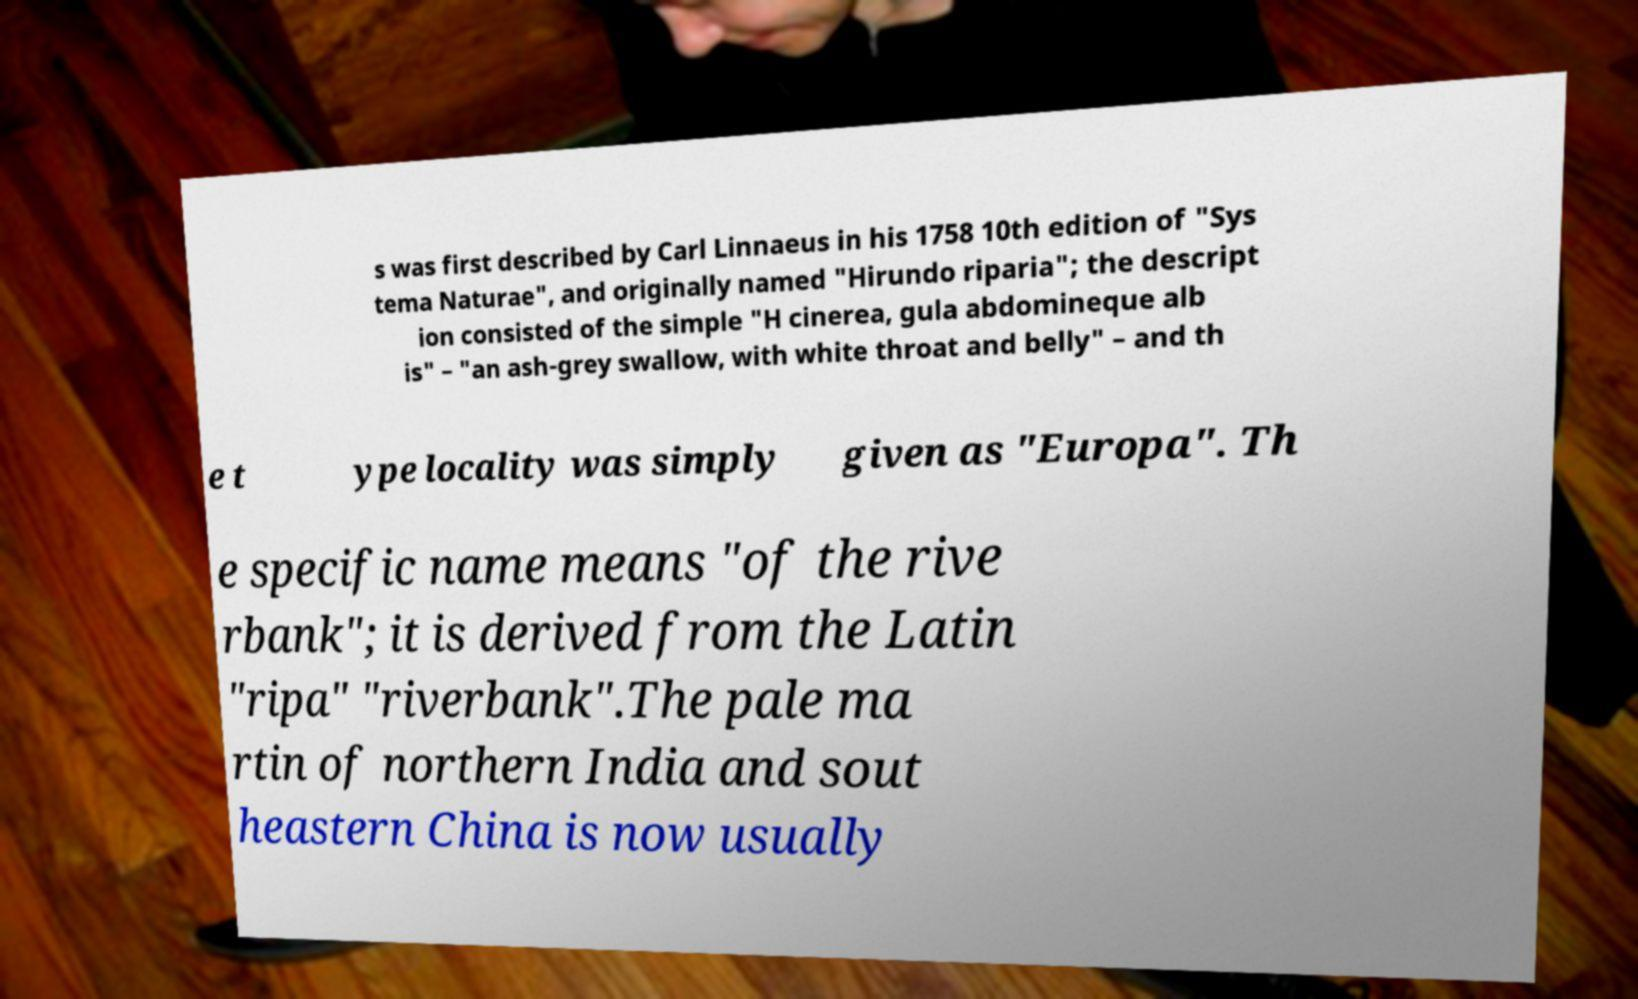Could you assist in decoding the text presented in this image and type it out clearly? s was first described by Carl Linnaeus in his 1758 10th edition of "Sys tema Naturae", and originally named "Hirundo riparia"; the descript ion consisted of the simple "H cinerea, gula abdomineque alb is" – "an ash-grey swallow, with white throat and belly" – and th e t ype locality was simply given as "Europa". Th e specific name means "of the rive rbank"; it is derived from the Latin "ripa" "riverbank".The pale ma rtin of northern India and sout heastern China is now usually 